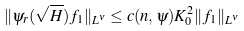<formula> <loc_0><loc_0><loc_500><loc_500>\| \psi _ { r } ( \sqrt { H } ) f _ { 1 } \| _ { L ^ { \nu } } \leq c ( n , \psi ) K _ { 0 } ^ { 2 } \| f _ { 1 } \| _ { L ^ { \nu } }</formula> 